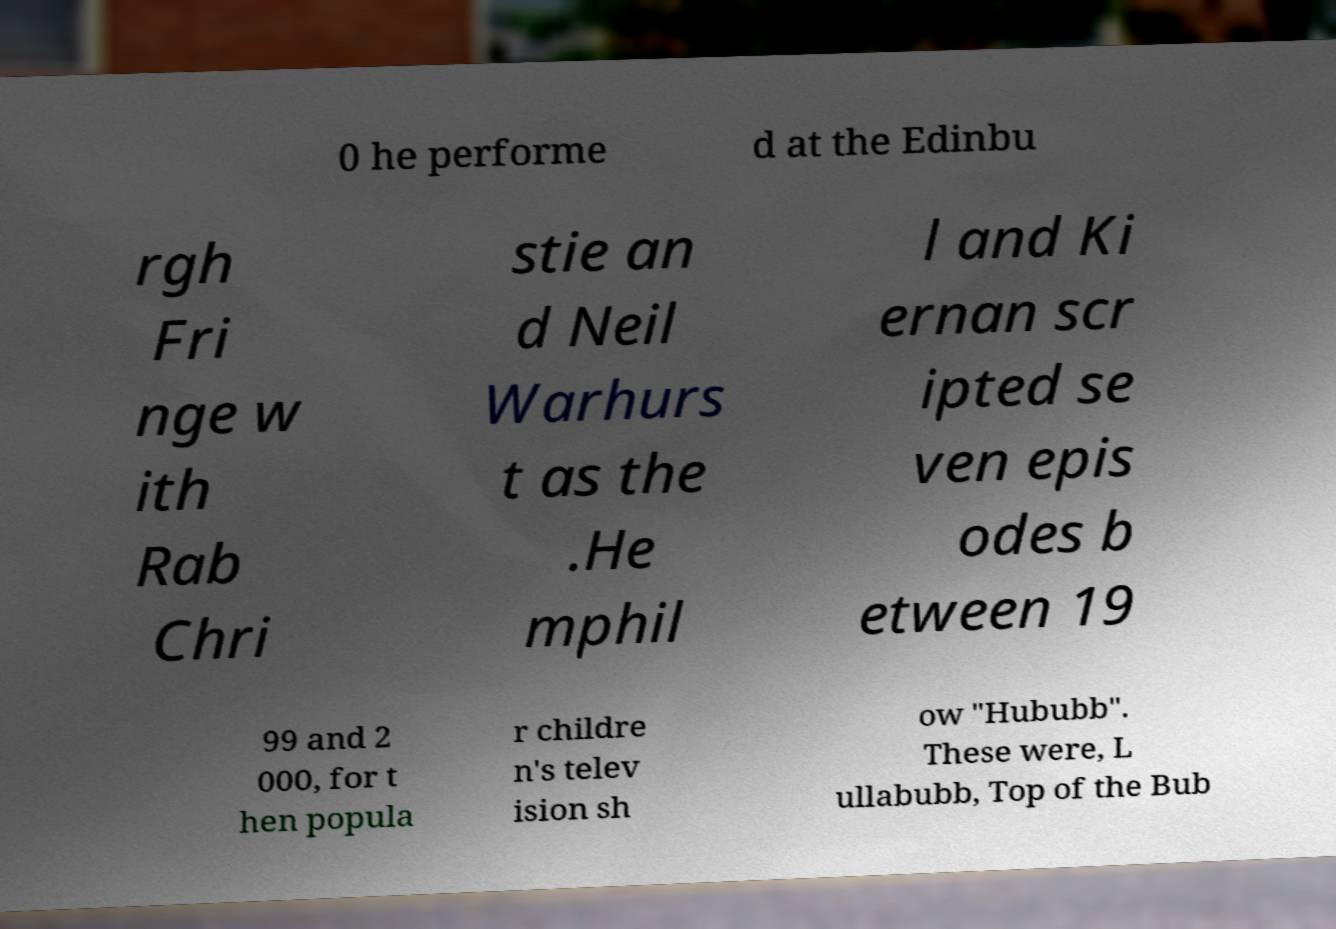For documentation purposes, I need the text within this image transcribed. Could you provide that? 0 he performe d at the Edinbu rgh Fri nge w ith Rab Chri stie an d Neil Warhurs t as the .He mphil l and Ki ernan scr ipted se ven epis odes b etween 19 99 and 2 000, for t hen popula r childre n's telev ision sh ow "Hububb". These were, L ullabubb, Top of the Bub 